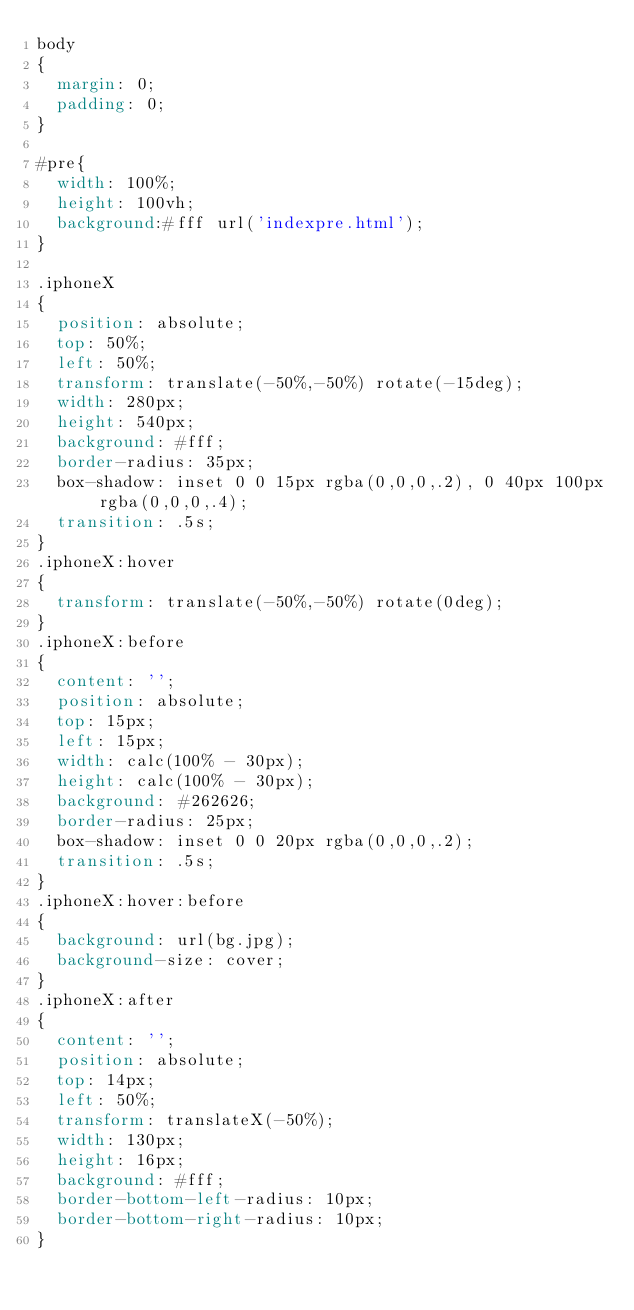<code> <loc_0><loc_0><loc_500><loc_500><_CSS_>body
{
	margin: 0;
	padding: 0;
}

#pre{
	width: 100%;
	height: 100vh;
	background:#fff url('indexpre.html');
}

.iphoneX
{
	position: absolute;
	top: 50%;
	left: 50%;
	transform: translate(-50%,-50%) rotate(-15deg);
	width: 280px;
	height: 540px;
	background: #fff;
	border-radius: 35px;
	box-shadow: inset 0 0 15px rgba(0,0,0,.2), 0 40px 100px rgba(0,0,0,.4);
	transition: .5s;
}
.iphoneX:hover
{
	transform: translate(-50%,-50%) rotate(0deg);
}
.iphoneX:before
{
	content: '';
	position: absolute;
	top: 15px;
	left: 15px;
	width: calc(100% - 30px);
	height: calc(100% - 30px);
	background: #262626;
	border-radius: 25px;
	box-shadow: inset 0 0 20px rgba(0,0,0,.2);
	transition: .5s;
}
.iphoneX:hover:before
{
	background: url(bg.jpg);
	background-size: cover;
}
.iphoneX:after
{
	content: '';
	position: absolute;
	top: 14px;
	left: 50%;
	transform: translateX(-50%);
	width: 130px;
	height: 16px;
	background: #fff;
	border-bottom-left-radius: 10px; 
	border-bottom-right-radius: 10px; 
}
</code> 